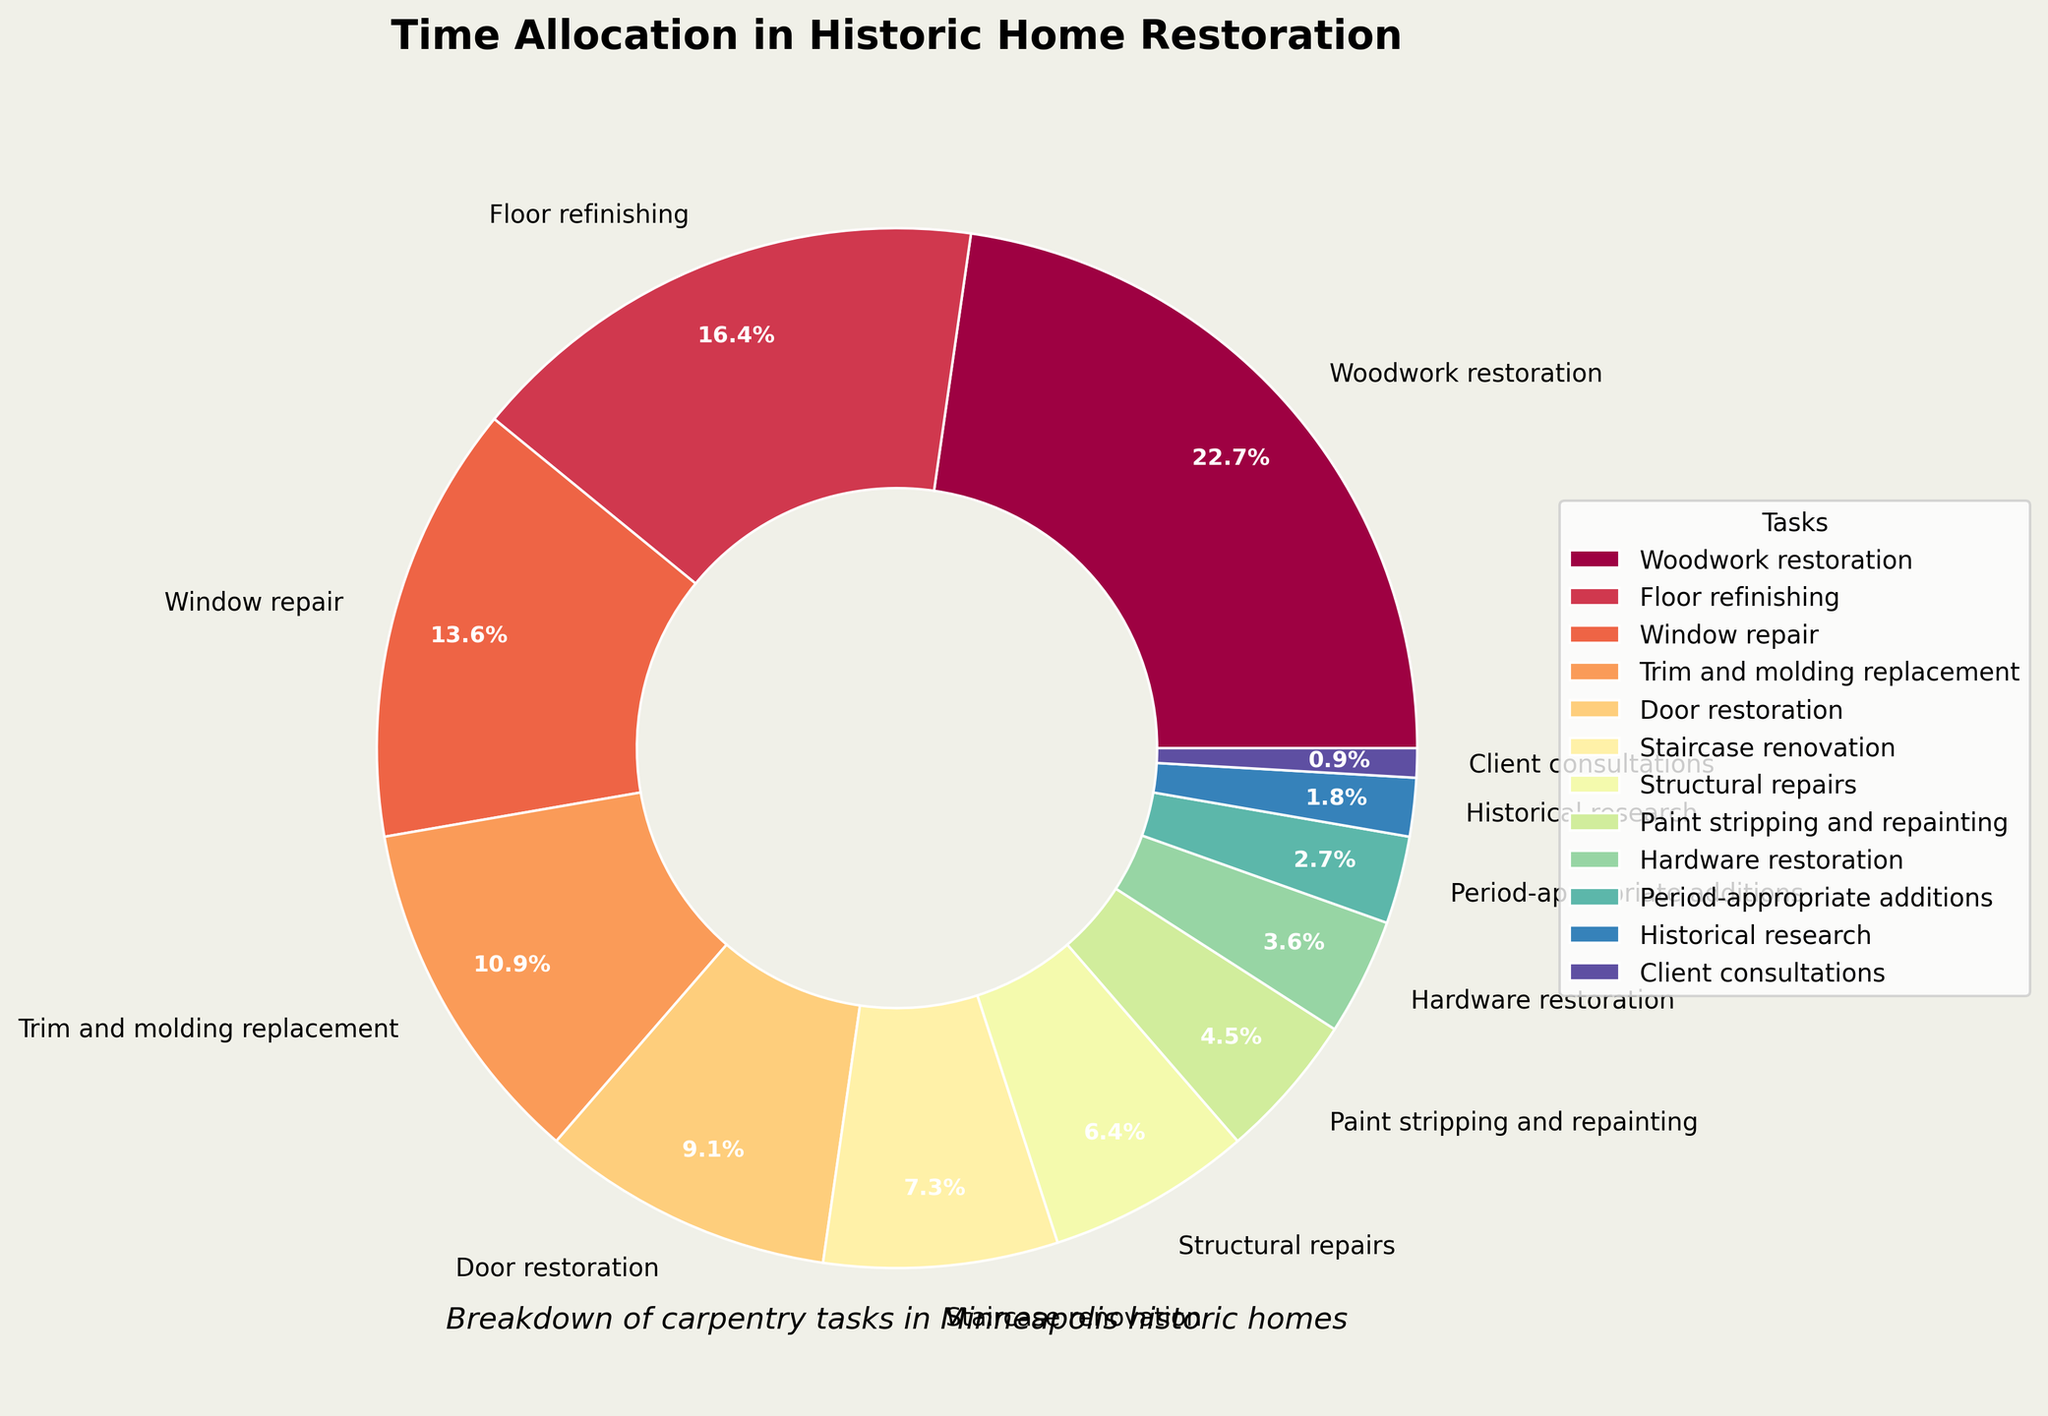Which task takes the largest percentage of time? To identify the task that takes the largest percentage of time, look for the largest wedge in the pie chart. The label on that wedge will indicate the task and the time percentage.
Answer: Woodwork restoration What is the combined percentage of time spent on Door restoration and Staircase renovation? Summing the percentages for Door restoration (10%) and Staircase renovation (8%) gives the combined time percentage. 10% + 8% = 18%
Answer: 18% How much more time is spent on Window repair compared to Period-appropriate additions? Subtract the percentage of time spent on Period-appropriate additions (3%) from the time spent on Window repair (15%). 15% - 3% = 12%
Answer: 12% Which tasks take less than 10% of the time? Identify the tasks whose wedges represent less than 10% by looking at the percentage labels on the pie chart. The tasks are Structural repairs (7%), Paint stripping and repainting (5%), Hardware restoration (4%), Period-appropriate additions (3%), Historical research (2%), and Client consultations (1%).
Answer: Structural repairs, Paint stripping and repainting, Hardware restoration, Period-appropriate additions, Historical research, Client consultations What is the total percentage of time spent on the top three tasks? Add the percentages for the top three tasks: Woodwork restoration (25%), Floor refinishing (18%), and Window repair (15%). 25% + 18% + 15% = 58%
Answer: 58% Which task has a smaller wedge: Trim and molding replacement or Paint stripping and repainting? Compare the percentages of Trim and molding replacement (12%) and Paint stripping and repainting (5%). The wedge with the smaller percentage is Paint stripping and repainting.
Answer: Paint stripping and repainting Assess whether more time is spent on Structural repairs or Historical research. Compare the percentages of Structural repairs (7%) and Historical research (2%). The wedge for Structural repairs is larger.
Answer: Structural repairs How much time is allocated to tasks related to doors and windows combined? Combine the percentages for Door restoration (10%) and Window repair (15%). 10% + 15% = 25%
Answer: 25% Find the difference in allocation percentage between Trim and molding replacement and Period-appropriate additions. Subtract the percentage of Period-appropriate additions (3%) from Trim and molding replacement (12%). 12% - 3% = 9%
Answer: 9% Which task category is represented by the smallest wedge? The smallest wedge corresponds to the task with the lowest percentage. According to the pie chart, this task is Client consultations at 1%.
Answer: Client consultations 